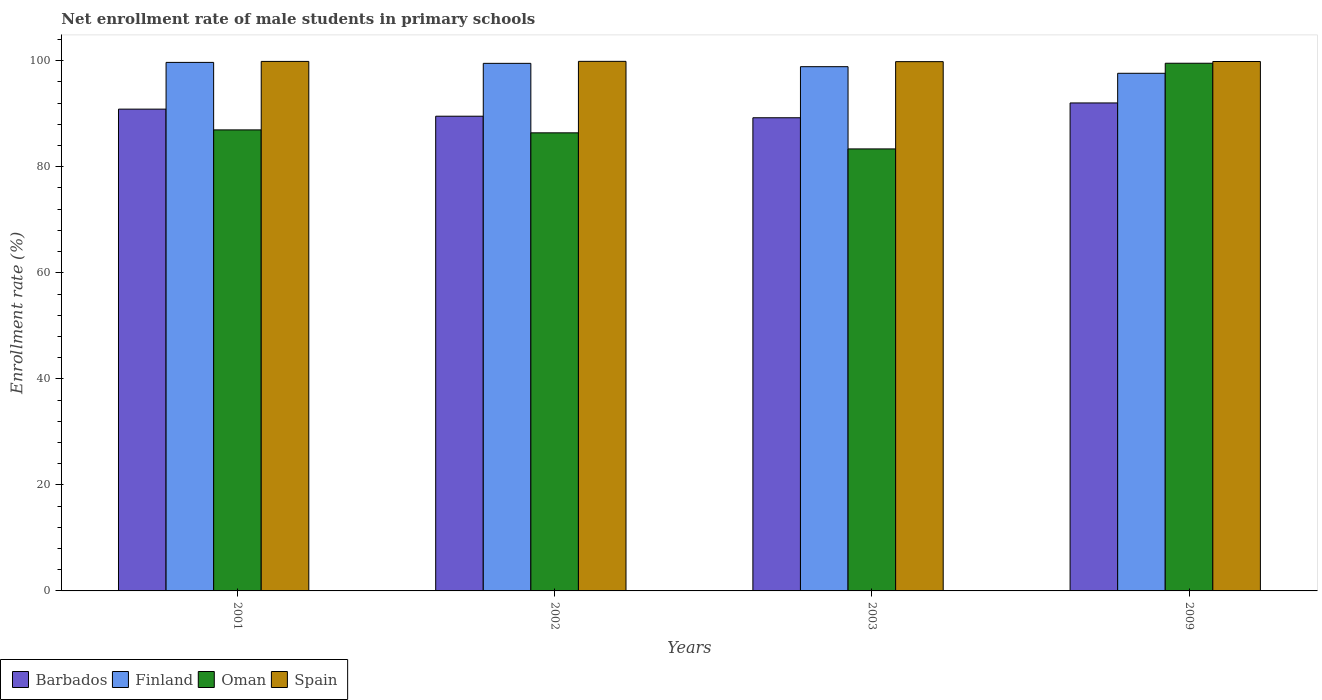Are the number of bars per tick equal to the number of legend labels?
Make the answer very short. Yes. How many bars are there on the 2nd tick from the left?
Ensure brevity in your answer.  4. How many bars are there on the 4th tick from the right?
Ensure brevity in your answer.  4. What is the label of the 4th group of bars from the left?
Your response must be concise. 2009. In how many cases, is the number of bars for a given year not equal to the number of legend labels?
Keep it short and to the point. 0. What is the net enrollment rate of male students in primary schools in Barbados in 2001?
Offer a terse response. 90.88. Across all years, what is the maximum net enrollment rate of male students in primary schools in Finland?
Make the answer very short. 99.69. Across all years, what is the minimum net enrollment rate of male students in primary schools in Barbados?
Give a very brief answer. 89.25. In which year was the net enrollment rate of male students in primary schools in Finland minimum?
Offer a terse response. 2009. What is the total net enrollment rate of male students in primary schools in Barbados in the graph?
Offer a terse response. 361.71. What is the difference between the net enrollment rate of male students in primary schools in Finland in 2001 and that in 2009?
Offer a terse response. 2.05. What is the difference between the net enrollment rate of male students in primary schools in Spain in 2001 and the net enrollment rate of male students in primary schools in Oman in 2009?
Offer a very short reply. 0.34. What is the average net enrollment rate of male students in primary schools in Spain per year?
Offer a terse response. 99.86. In the year 2002, what is the difference between the net enrollment rate of male students in primary schools in Spain and net enrollment rate of male students in primary schools in Finland?
Ensure brevity in your answer.  0.38. In how many years, is the net enrollment rate of male students in primary schools in Barbados greater than 8 %?
Offer a terse response. 4. What is the ratio of the net enrollment rate of male students in primary schools in Spain in 2001 to that in 2003?
Ensure brevity in your answer.  1. Is the difference between the net enrollment rate of male students in primary schools in Spain in 2001 and 2003 greater than the difference between the net enrollment rate of male students in primary schools in Finland in 2001 and 2003?
Give a very brief answer. No. What is the difference between the highest and the second highest net enrollment rate of male students in primary schools in Oman?
Ensure brevity in your answer.  12.57. What is the difference between the highest and the lowest net enrollment rate of male students in primary schools in Finland?
Provide a short and direct response. 2.05. In how many years, is the net enrollment rate of male students in primary schools in Barbados greater than the average net enrollment rate of male students in primary schools in Barbados taken over all years?
Your response must be concise. 2. Is the sum of the net enrollment rate of male students in primary schools in Spain in 2001 and 2002 greater than the maximum net enrollment rate of male students in primary schools in Oman across all years?
Ensure brevity in your answer.  Yes. What does the 2nd bar from the left in 2001 represents?
Your answer should be very brief. Finland. Are all the bars in the graph horizontal?
Keep it short and to the point. No. How many years are there in the graph?
Your response must be concise. 4. Does the graph contain any zero values?
Provide a short and direct response. No. Does the graph contain grids?
Your answer should be very brief. No. How are the legend labels stacked?
Ensure brevity in your answer.  Horizontal. What is the title of the graph?
Give a very brief answer. Net enrollment rate of male students in primary schools. Does "Niger" appear as one of the legend labels in the graph?
Your answer should be compact. No. What is the label or title of the X-axis?
Make the answer very short. Years. What is the label or title of the Y-axis?
Make the answer very short. Enrollment rate (%). What is the Enrollment rate (%) of Barbados in 2001?
Your response must be concise. 90.88. What is the Enrollment rate (%) in Finland in 2001?
Make the answer very short. 99.69. What is the Enrollment rate (%) of Oman in 2001?
Your response must be concise. 86.96. What is the Enrollment rate (%) of Spain in 2001?
Your answer should be very brief. 99.88. What is the Enrollment rate (%) of Barbados in 2002?
Offer a terse response. 89.54. What is the Enrollment rate (%) in Finland in 2002?
Make the answer very short. 99.51. What is the Enrollment rate (%) in Oman in 2002?
Give a very brief answer. 86.4. What is the Enrollment rate (%) of Spain in 2002?
Give a very brief answer. 99.89. What is the Enrollment rate (%) in Barbados in 2003?
Your answer should be compact. 89.25. What is the Enrollment rate (%) of Finland in 2003?
Offer a terse response. 98.88. What is the Enrollment rate (%) of Oman in 2003?
Provide a succinct answer. 83.37. What is the Enrollment rate (%) in Spain in 2003?
Your response must be concise. 99.83. What is the Enrollment rate (%) in Barbados in 2009?
Give a very brief answer. 92.04. What is the Enrollment rate (%) in Finland in 2009?
Provide a succinct answer. 97.64. What is the Enrollment rate (%) of Oman in 2009?
Provide a short and direct response. 99.53. What is the Enrollment rate (%) in Spain in 2009?
Make the answer very short. 99.86. Across all years, what is the maximum Enrollment rate (%) in Barbados?
Give a very brief answer. 92.04. Across all years, what is the maximum Enrollment rate (%) of Finland?
Offer a terse response. 99.69. Across all years, what is the maximum Enrollment rate (%) of Oman?
Make the answer very short. 99.53. Across all years, what is the maximum Enrollment rate (%) of Spain?
Ensure brevity in your answer.  99.89. Across all years, what is the minimum Enrollment rate (%) in Barbados?
Offer a very short reply. 89.25. Across all years, what is the minimum Enrollment rate (%) of Finland?
Give a very brief answer. 97.64. Across all years, what is the minimum Enrollment rate (%) of Oman?
Give a very brief answer. 83.37. Across all years, what is the minimum Enrollment rate (%) of Spain?
Offer a very short reply. 99.83. What is the total Enrollment rate (%) in Barbados in the graph?
Ensure brevity in your answer.  361.71. What is the total Enrollment rate (%) of Finland in the graph?
Provide a short and direct response. 395.72. What is the total Enrollment rate (%) of Oman in the graph?
Offer a very short reply. 356.27. What is the total Enrollment rate (%) of Spain in the graph?
Offer a very short reply. 399.46. What is the difference between the Enrollment rate (%) in Barbados in 2001 and that in 2002?
Keep it short and to the point. 1.33. What is the difference between the Enrollment rate (%) in Finland in 2001 and that in 2002?
Your answer should be very brief. 0.18. What is the difference between the Enrollment rate (%) of Oman in 2001 and that in 2002?
Make the answer very short. 0.56. What is the difference between the Enrollment rate (%) of Spain in 2001 and that in 2002?
Ensure brevity in your answer.  -0.01. What is the difference between the Enrollment rate (%) of Barbados in 2001 and that in 2003?
Provide a succinct answer. 1.63. What is the difference between the Enrollment rate (%) of Finland in 2001 and that in 2003?
Provide a short and direct response. 0.81. What is the difference between the Enrollment rate (%) of Oman in 2001 and that in 2003?
Your answer should be very brief. 3.59. What is the difference between the Enrollment rate (%) in Spain in 2001 and that in 2003?
Your response must be concise. 0.04. What is the difference between the Enrollment rate (%) in Barbados in 2001 and that in 2009?
Your answer should be compact. -1.17. What is the difference between the Enrollment rate (%) in Finland in 2001 and that in 2009?
Keep it short and to the point. 2.05. What is the difference between the Enrollment rate (%) of Oman in 2001 and that in 2009?
Offer a terse response. -12.57. What is the difference between the Enrollment rate (%) in Spain in 2001 and that in 2009?
Keep it short and to the point. 0.02. What is the difference between the Enrollment rate (%) of Barbados in 2002 and that in 2003?
Make the answer very short. 0.29. What is the difference between the Enrollment rate (%) in Finland in 2002 and that in 2003?
Provide a short and direct response. 0.63. What is the difference between the Enrollment rate (%) of Oman in 2002 and that in 2003?
Your response must be concise. 3.03. What is the difference between the Enrollment rate (%) in Spain in 2002 and that in 2003?
Provide a succinct answer. 0.06. What is the difference between the Enrollment rate (%) in Barbados in 2002 and that in 2009?
Your response must be concise. -2.5. What is the difference between the Enrollment rate (%) of Finland in 2002 and that in 2009?
Offer a very short reply. 1.87. What is the difference between the Enrollment rate (%) of Oman in 2002 and that in 2009?
Your response must be concise. -13.13. What is the difference between the Enrollment rate (%) in Spain in 2002 and that in 2009?
Keep it short and to the point. 0.03. What is the difference between the Enrollment rate (%) of Barbados in 2003 and that in 2009?
Your answer should be compact. -2.79. What is the difference between the Enrollment rate (%) of Finland in 2003 and that in 2009?
Provide a short and direct response. 1.25. What is the difference between the Enrollment rate (%) of Oman in 2003 and that in 2009?
Your answer should be very brief. -16.16. What is the difference between the Enrollment rate (%) in Spain in 2003 and that in 2009?
Make the answer very short. -0.03. What is the difference between the Enrollment rate (%) of Barbados in 2001 and the Enrollment rate (%) of Finland in 2002?
Your response must be concise. -8.63. What is the difference between the Enrollment rate (%) of Barbados in 2001 and the Enrollment rate (%) of Oman in 2002?
Your answer should be very brief. 4.47. What is the difference between the Enrollment rate (%) in Barbados in 2001 and the Enrollment rate (%) in Spain in 2002?
Your answer should be very brief. -9.01. What is the difference between the Enrollment rate (%) of Finland in 2001 and the Enrollment rate (%) of Oman in 2002?
Your answer should be compact. 13.29. What is the difference between the Enrollment rate (%) in Finland in 2001 and the Enrollment rate (%) in Spain in 2002?
Provide a short and direct response. -0.2. What is the difference between the Enrollment rate (%) of Oman in 2001 and the Enrollment rate (%) of Spain in 2002?
Your answer should be very brief. -12.93. What is the difference between the Enrollment rate (%) of Barbados in 2001 and the Enrollment rate (%) of Finland in 2003?
Offer a very short reply. -8.01. What is the difference between the Enrollment rate (%) in Barbados in 2001 and the Enrollment rate (%) in Oman in 2003?
Ensure brevity in your answer.  7.5. What is the difference between the Enrollment rate (%) in Barbados in 2001 and the Enrollment rate (%) in Spain in 2003?
Your answer should be compact. -8.96. What is the difference between the Enrollment rate (%) of Finland in 2001 and the Enrollment rate (%) of Oman in 2003?
Provide a succinct answer. 16.32. What is the difference between the Enrollment rate (%) of Finland in 2001 and the Enrollment rate (%) of Spain in 2003?
Your response must be concise. -0.14. What is the difference between the Enrollment rate (%) of Oman in 2001 and the Enrollment rate (%) of Spain in 2003?
Offer a very short reply. -12.87. What is the difference between the Enrollment rate (%) of Barbados in 2001 and the Enrollment rate (%) of Finland in 2009?
Offer a very short reply. -6.76. What is the difference between the Enrollment rate (%) in Barbados in 2001 and the Enrollment rate (%) in Oman in 2009?
Provide a succinct answer. -8.66. What is the difference between the Enrollment rate (%) in Barbados in 2001 and the Enrollment rate (%) in Spain in 2009?
Keep it short and to the point. -8.98. What is the difference between the Enrollment rate (%) in Finland in 2001 and the Enrollment rate (%) in Oman in 2009?
Your answer should be very brief. 0.16. What is the difference between the Enrollment rate (%) in Finland in 2001 and the Enrollment rate (%) in Spain in 2009?
Your answer should be very brief. -0.17. What is the difference between the Enrollment rate (%) in Oman in 2001 and the Enrollment rate (%) in Spain in 2009?
Make the answer very short. -12.9. What is the difference between the Enrollment rate (%) in Barbados in 2002 and the Enrollment rate (%) in Finland in 2003?
Provide a succinct answer. -9.34. What is the difference between the Enrollment rate (%) of Barbados in 2002 and the Enrollment rate (%) of Oman in 2003?
Your answer should be compact. 6.17. What is the difference between the Enrollment rate (%) of Barbados in 2002 and the Enrollment rate (%) of Spain in 2003?
Your answer should be very brief. -10.29. What is the difference between the Enrollment rate (%) of Finland in 2002 and the Enrollment rate (%) of Oman in 2003?
Your answer should be very brief. 16.14. What is the difference between the Enrollment rate (%) in Finland in 2002 and the Enrollment rate (%) in Spain in 2003?
Provide a succinct answer. -0.32. What is the difference between the Enrollment rate (%) in Oman in 2002 and the Enrollment rate (%) in Spain in 2003?
Provide a short and direct response. -13.43. What is the difference between the Enrollment rate (%) in Barbados in 2002 and the Enrollment rate (%) in Finland in 2009?
Offer a very short reply. -8.1. What is the difference between the Enrollment rate (%) of Barbados in 2002 and the Enrollment rate (%) of Oman in 2009?
Give a very brief answer. -9.99. What is the difference between the Enrollment rate (%) of Barbados in 2002 and the Enrollment rate (%) of Spain in 2009?
Your response must be concise. -10.32. What is the difference between the Enrollment rate (%) in Finland in 2002 and the Enrollment rate (%) in Oman in 2009?
Ensure brevity in your answer.  -0.02. What is the difference between the Enrollment rate (%) of Finland in 2002 and the Enrollment rate (%) of Spain in 2009?
Provide a short and direct response. -0.35. What is the difference between the Enrollment rate (%) in Oman in 2002 and the Enrollment rate (%) in Spain in 2009?
Make the answer very short. -13.46. What is the difference between the Enrollment rate (%) in Barbados in 2003 and the Enrollment rate (%) in Finland in 2009?
Offer a terse response. -8.39. What is the difference between the Enrollment rate (%) in Barbados in 2003 and the Enrollment rate (%) in Oman in 2009?
Offer a terse response. -10.28. What is the difference between the Enrollment rate (%) in Barbados in 2003 and the Enrollment rate (%) in Spain in 2009?
Offer a terse response. -10.61. What is the difference between the Enrollment rate (%) in Finland in 2003 and the Enrollment rate (%) in Oman in 2009?
Your response must be concise. -0.65. What is the difference between the Enrollment rate (%) of Finland in 2003 and the Enrollment rate (%) of Spain in 2009?
Your answer should be very brief. -0.98. What is the difference between the Enrollment rate (%) of Oman in 2003 and the Enrollment rate (%) of Spain in 2009?
Your answer should be compact. -16.49. What is the average Enrollment rate (%) in Barbados per year?
Keep it short and to the point. 90.43. What is the average Enrollment rate (%) of Finland per year?
Your answer should be compact. 98.93. What is the average Enrollment rate (%) of Oman per year?
Your response must be concise. 89.07. What is the average Enrollment rate (%) in Spain per year?
Your response must be concise. 99.86. In the year 2001, what is the difference between the Enrollment rate (%) of Barbados and Enrollment rate (%) of Finland?
Your answer should be compact. -8.81. In the year 2001, what is the difference between the Enrollment rate (%) of Barbados and Enrollment rate (%) of Oman?
Ensure brevity in your answer.  3.92. In the year 2001, what is the difference between the Enrollment rate (%) of Barbados and Enrollment rate (%) of Spain?
Keep it short and to the point. -9. In the year 2001, what is the difference between the Enrollment rate (%) in Finland and Enrollment rate (%) in Oman?
Your answer should be compact. 12.73. In the year 2001, what is the difference between the Enrollment rate (%) in Finland and Enrollment rate (%) in Spain?
Your answer should be compact. -0.19. In the year 2001, what is the difference between the Enrollment rate (%) of Oman and Enrollment rate (%) of Spain?
Your response must be concise. -12.92. In the year 2002, what is the difference between the Enrollment rate (%) in Barbados and Enrollment rate (%) in Finland?
Give a very brief answer. -9.97. In the year 2002, what is the difference between the Enrollment rate (%) of Barbados and Enrollment rate (%) of Oman?
Your answer should be compact. 3.14. In the year 2002, what is the difference between the Enrollment rate (%) in Barbados and Enrollment rate (%) in Spain?
Offer a very short reply. -10.35. In the year 2002, what is the difference between the Enrollment rate (%) in Finland and Enrollment rate (%) in Oman?
Make the answer very short. 13.11. In the year 2002, what is the difference between the Enrollment rate (%) of Finland and Enrollment rate (%) of Spain?
Your answer should be compact. -0.38. In the year 2002, what is the difference between the Enrollment rate (%) of Oman and Enrollment rate (%) of Spain?
Provide a succinct answer. -13.48. In the year 2003, what is the difference between the Enrollment rate (%) in Barbados and Enrollment rate (%) in Finland?
Your answer should be very brief. -9.63. In the year 2003, what is the difference between the Enrollment rate (%) in Barbados and Enrollment rate (%) in Oman?
Your answer should be compact. 5.88. In the year 2003, what is the difference between the Enrollment rate (%) of Barbados and Enrollment rate (%) of Spain?
Offer a very short reply. -10.58. In the year 2003, what is the difference between the Enrollment rate (%) of Finland and Enrollment rate (%) of Oman?
Give a very brief answer. 15.51. In the year 2003, what is the difference between the Enrollment rate (%) of Finland and Enrollment rate (%) of Spain?
Your response must be concise. -0.95. In the year 2003, what is the difference between the Enrollment rate (%) in Oman and Enrollment rate (%) in Spain?
Offer a terse response. -16.46. In the year 2009, what is the difference between the Enrollment rate (%) in Barbados and Enrollment rate (%) in Finland?
Your response must be concise. -5.59. In the year 2009, what is the difference between the Enrollment rate (%) of Barbados and Enrollment rate (%) of Oman?
Give a very brief answer. -7.49. In the year 2009, what is the difference between the Enrollment rate (%) of Barbados and Enrollment rate (%) of Spain?
Your response must be concise. -7.82. In the year 2009, what is the difference between the Enrollment rate (%) in Finland and Enrollment rate (%) in Oman?
Ensure brevity in your answer.  -1.89. In the year 2009, what is the difference between the Enrollment rate (%) in Finland and Enrollment rate (%) in Spain?
Provide a succinct answer. -2.22. In the year 2009, what is the difference between the Enrollment rate (%) in Oman and Enrollment rate (%) in Spain?
Give a very brief answer. -0.33. What is the ratio of the Enrollment rate (%) in Barbados in 2001 to that in 2002?
Your answer should be compact. 1.01. What is the ratio of the Enrollment rate (%) of Oman in 2001 to that in 2002?
Keep it short and to the point. 1.01. What is the ratio of the Enrollment rate (%) in Spain in 2001 to that in 2002?
Ensure brevity in your answer.  1. What is the ratio of the Enrollment rate (%) of Barbados in 2001 to that in 2003?
Make the answer very short. 1.02. What is the ratio of the Enrollment rate (%) of Oman in 2001 to that in 2003?
Make the answer very short. 1.04. What is the ratio of the Enrollment rate (%) of Barbados in 2001 to that in 2009?
Keep it short and to the point. 0.99. What is the ratio of the Enrollment rate (%) of Oman in 2001 to that in 2009?
Ensure brevity in your answer.  0.87. What is the ratio of the Enrollment rate (%) in Oman in 2002 to that in 2003?
Provide a succinct answer. 1.04. What is the ratio of the Enrollment rate (%) in Barbados in 2002 to that in 2009?
Offer a very short reply. 0.97. What is the ratio of the Enrollment rate (%) of Finland in 2002 to that in 2009?
Offer a terse response. 1.02. What is the ratio of the Enrollment rate (%) in Oman in 2002 to that in 2009?
Provide a succinct answer. 0.87. What is the ratio of the Enrollment rate (%) in Barbados in 2003 to that in 2009?
Your answer should be very brief. 0.97. What is the ratio of the Enrollment rate (%) of Finland in 2003 to that in 2009?
Provide a short and direct response. 1.01. What is the ratio of the Enrollment rate (%) in Oman in 2003 to that in 2009?
Provide a succinct answer. 0.84. What is the ratio of the Enrollment rate (%) of Spain in 2003 to that in 2009?
Keep it short and to the point. 1. What is the difference between the highest and the second highest Enrollment rate (%) in Barbados?
Offer a terse response. 1.17. What is the difference between the highest and the second highest Enrollment rate (%) of Finland?
Your answer should be very brief. 0.18. What is the difference between the highest and the second highest Enrollment rate (%) in Oman?
Provide a succinct answer. 12.57. What is the difference between the highest and the second highest Enrollment rate (%) in Spain?
Offer a very short reply. 0.01. What is the difference between the highest and the lowest Enrollment rate (%) of Barbados?
Make the answer very short. 2.79. What is the difference between the highest and the lowest Enrollment rate (%) in Finland?
Make the answer very short. 2.05. What is the difference between the highest and the lowest Enrollment rate (%) of Oman?
Offer a terse response. 16.16. What is the difference between the highest and the lowest Enrollment rate (%) in Spain?
Keep it short and to the point. 0.06. 